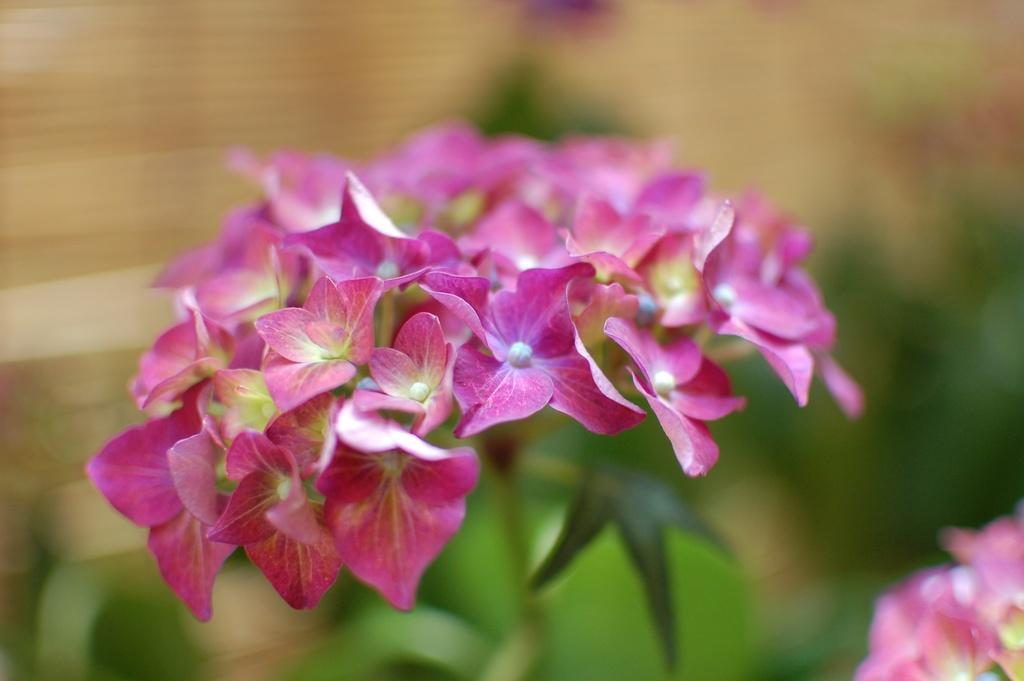Could you give a brief overview of what you see in this image? In this image we can see pink color flowers with blur background. 